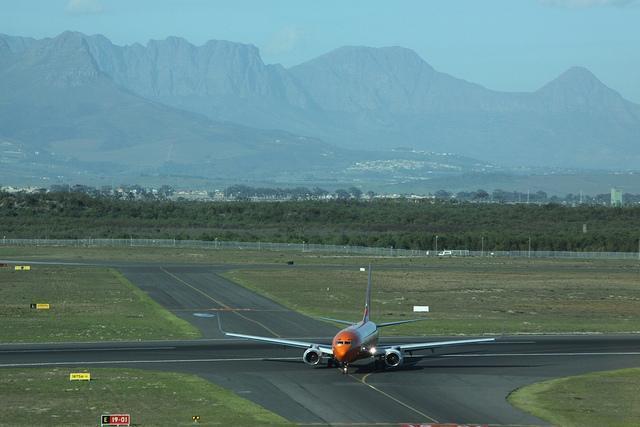How many engines does the plane have?
Give a very brief answer. 2. How many airplanes with light blue paint are visible in this photograph?
Give a very brief answer. 0. 